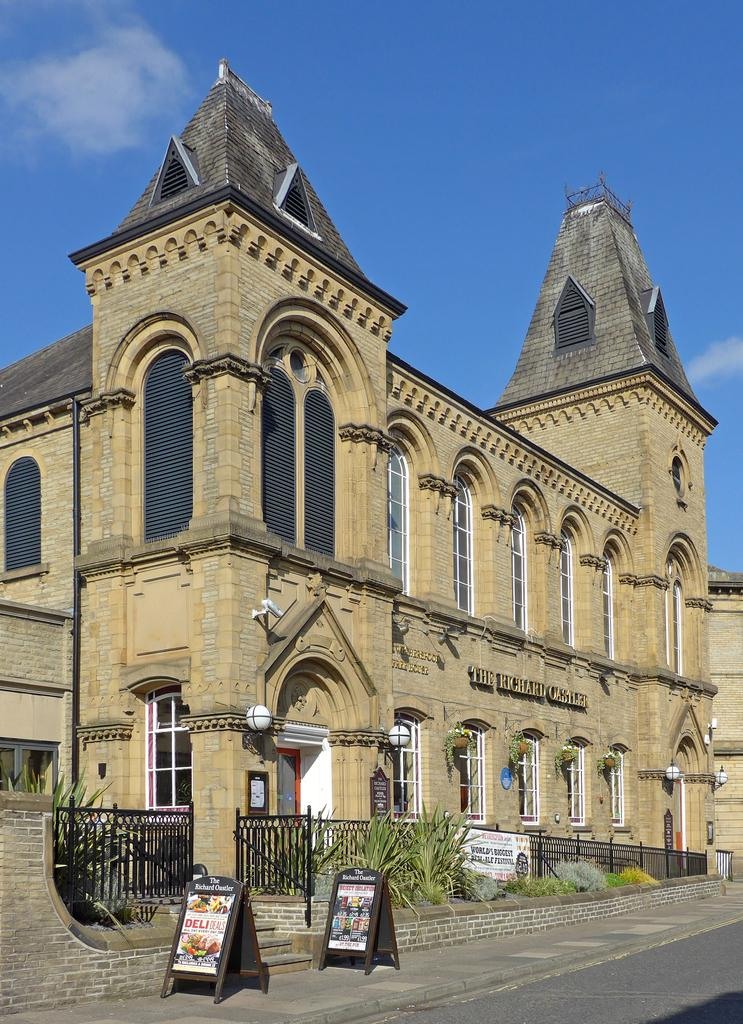What can be seen in the sky in the image? A: The sky with clouds is visible in the image. What type of structure is present in the image? There is a building in the image. What is the purpose of the pipeline in the image? The purpose of the pipeline is not specified in the image, but it is likely for transporting fluids or gases. What is used for surveillance in the image? A CCTV camera is visible in the image for surveillance purposes. What is the name of the place or establishment in the image? There is a name board in the image, which indicates the name of the place or establishment. What type of barrier is present in the image? Grills are present in the image as a barrier or fence. What is used for advertising in the image? Advertisement boards are visible in the image for advertising purposes. What type of vegetation is present in the image? Plants and shrubs are visible in the image as vegetation. How many trees are present in the image? There are no trees present in the image; only plants and shrubs are visible as vegetation. What type of vase is visible in the image? There is no vase present in the image. 